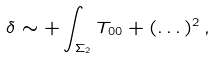Convert formula to latex. <formula><loc_0><loc_0><loc_500><loc_500>\delta \sim + \int _ { \Sigma _ { 2 } } T _ { 0 0 } + ( \dots ) ^ { 2 } \, ,</formula> 